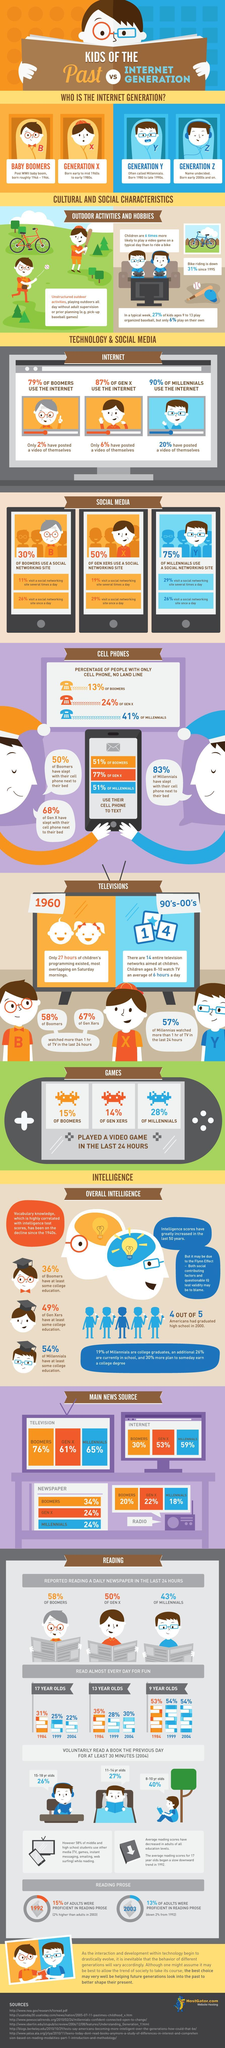What percentage of millennials have posted a video of themselves?
Answer the question with a short phrase. 20 What percentage of millennials use Internet as news source? 59% What percentage of boomers use cell phone to text? 51% What are people born during mid 1960s to early 1980s usually referred as? Generation X What term is used to classify people born during the period 1946-1964? Baby Boomers What percentage of Gen X use Television as news source? 61% What percentage of gen Xers visit a social networking site several times a day? 19 What percentage of millennials played a video game in the last 24 hours? 28% What are people born in early 2000s and on referred to as? Generation Z What percentage of boomers reported reading daily newspaper? 58% 